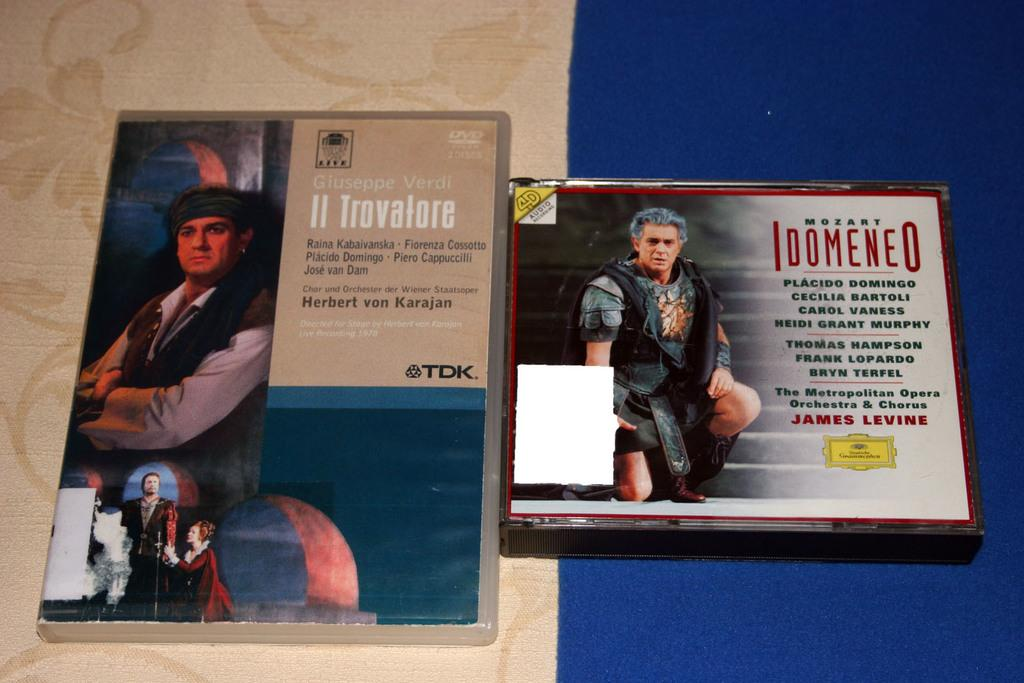<image>
Share a concise interpretation of the image provided. The dvd on the right is labeled Mozart Idomeneo. 